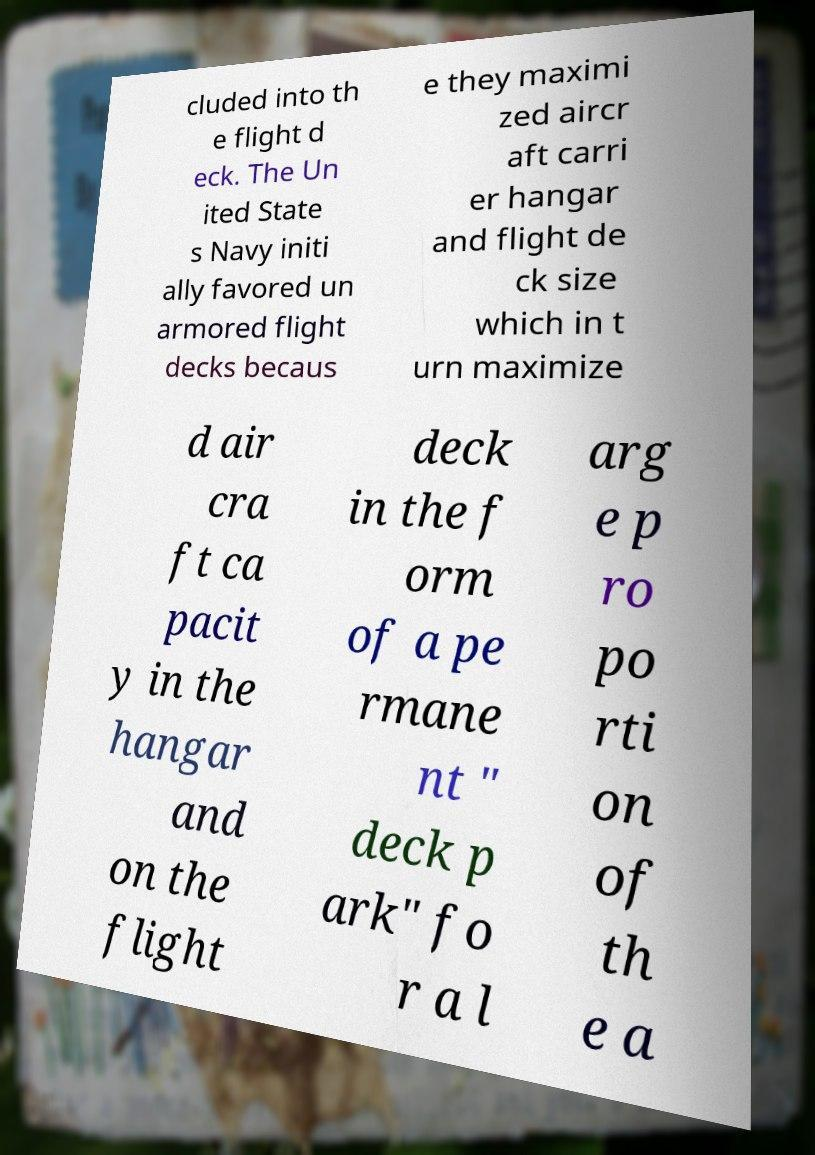For documentation purposes, I need the text within this image transcribed. Could you provide that? cluded into th e flight d eck. The Un ited State s Navy initi ally favored un armored flight decks becaus e they maximi zed aircr aft carri er hangar and flight de ck size which in t urn maximize d air cra ft ca pacit y in the hangar and on the flight deck in the f orm of a pe rmane nt " deck p ark" fo r a l arg e p ro po rti on of th e a 